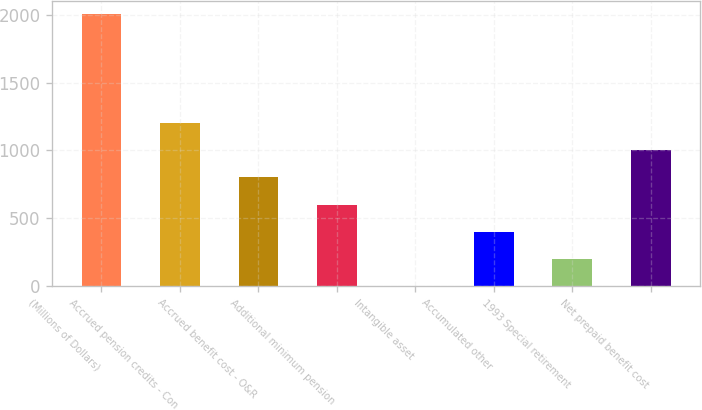Convert chart to OTSL. <chart><loc_0><loc_0><loc_500><loc_500><bar_chart><fcel>(Millions of Dollars)<fcel>Accrued pension credits - Con<fcel>Accrued benefit cost - O&R<fcel>Additional minimum pension<fcel>Intangible asset<fcel>Accumulated other<fcel>1993 Special retirement<fcel>Net prepaid benefit cost<nl><fcel>2002<fcel>1201.28<fcel>800.92<fcel>600.74<fcel>0.2<fcel>400.56<fcel>200.38<fcel>1001.1<nl></chart> 